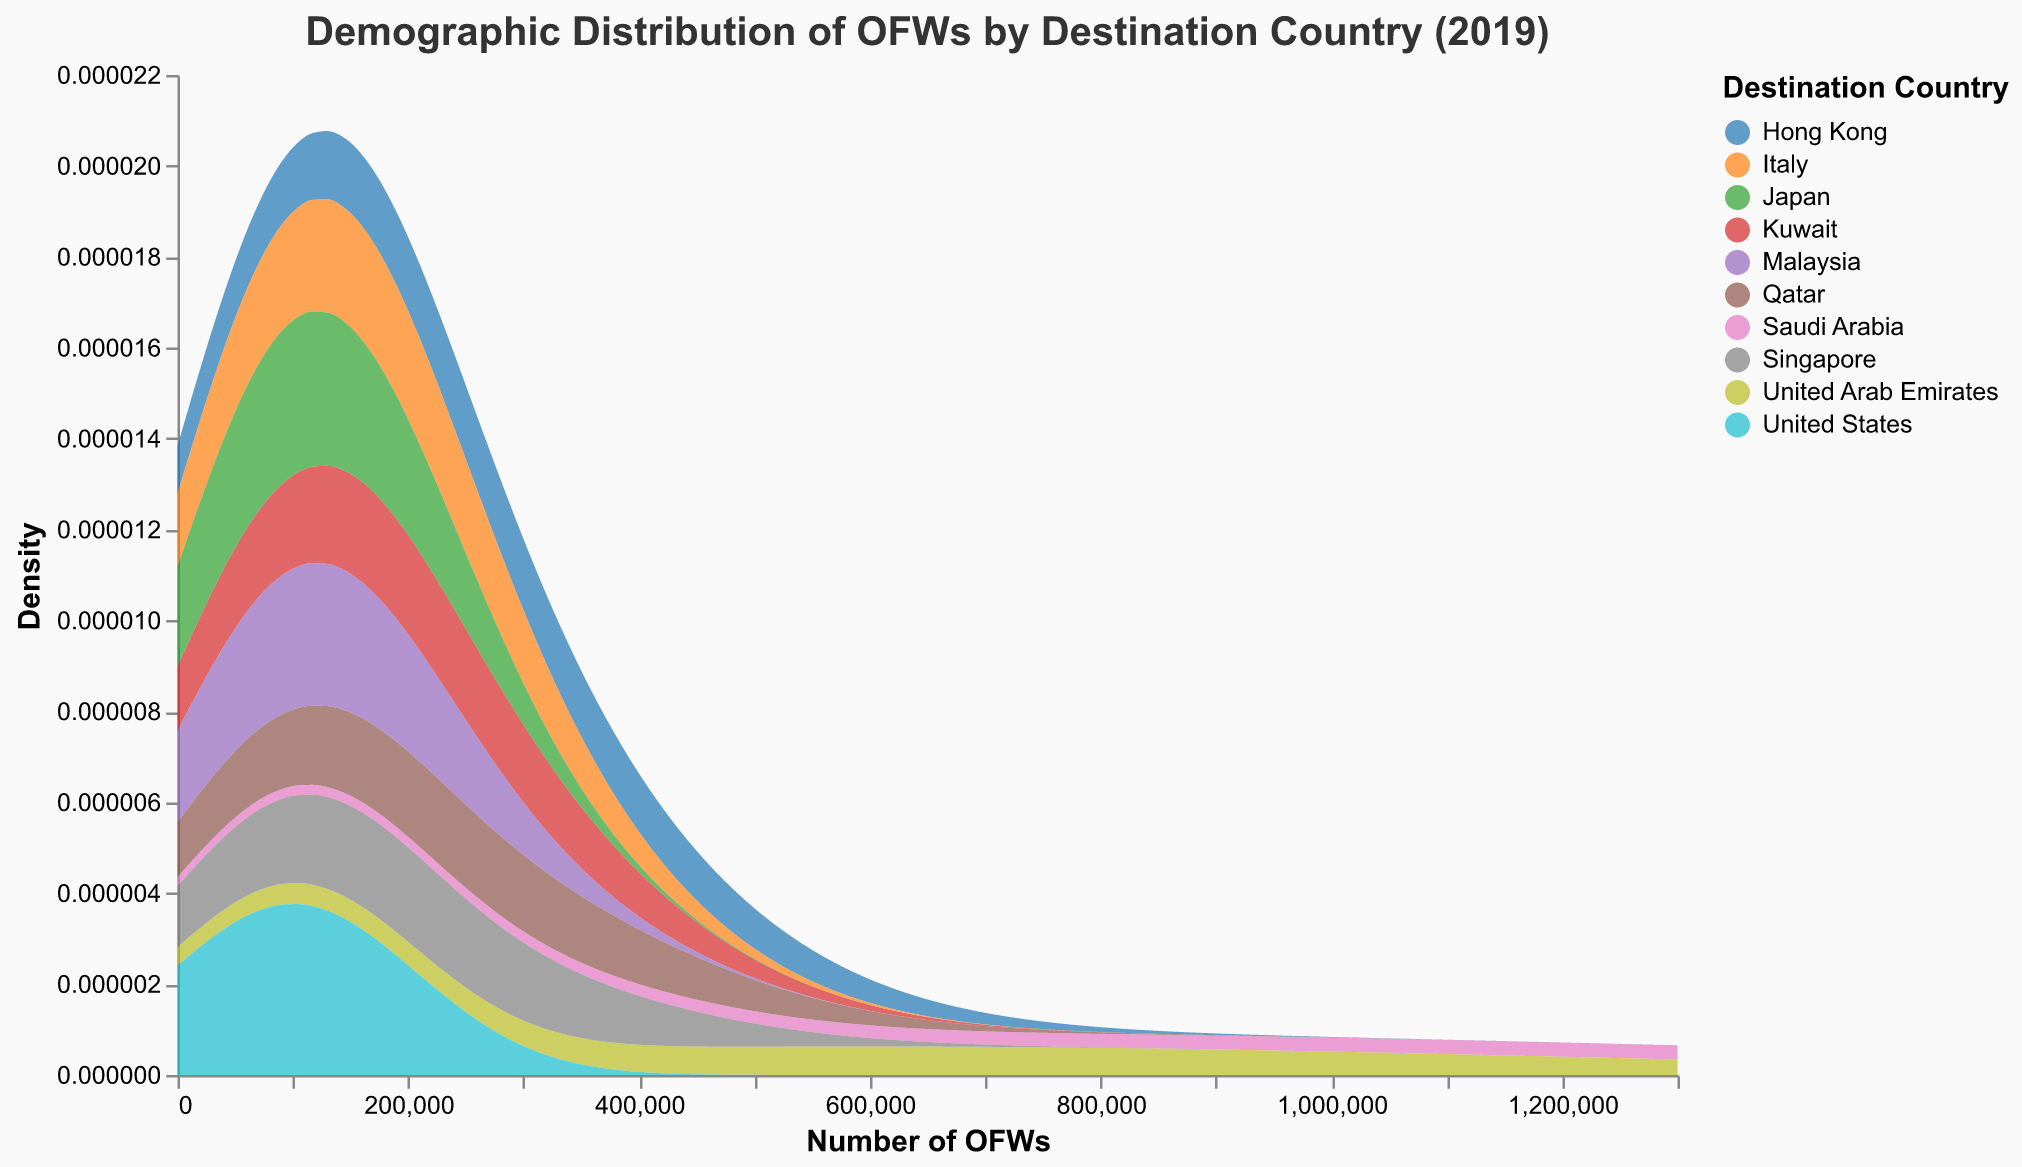What is the title of the figure? The title is clearly shown at the top of the figure.
Answer: Demographic Distribution of OFWs by Destination Country (2019) How many destination countries are represented in the figure? Count the number of different colors in the density plot, as each color corresponds to a different country.
Answer: 10 Which country has the highest density of OFWs? Identify the peak density for each country and find the one with the highest peak.
Answer: Saudi Arabia What is the range of the number of OFWs represented on the x-axis? Look at the x-axis labels to determine the minimum and maximum values.
Answer: 0 to 1,300,000 Which country has the second highest number of OFWs? Refer to the labels and the density plot to find the country with the second highest peak in density.
Answer: United Arab Emirates What is the color used to represent Italy in the figure? Identify the legend and find the color corresponding to Italy.
Answer: Specific color from the category10 scheme (e.g., red) How does the distribution of OFWs for Qatar compare to that for Singapore? Compare the density plots for Qatar and Singapore by looking at their shapes and peak values.
Answer: Qatar has a slightly higher peak density than Singapore Is there a country with a density plot that is significantly different from the others? If so, which one? Observe if any country's density plot stands out significantly in shape or peak from the others.
Answer: Saudi Arabia What is the approximate density value for Japan? Identify the density plot for Japan and observe the peak value on the y-axis.
Answer: Approximately 0.00001 (example value) Between Malaysia and Japan, which country has a higher density of OFWs? Compare the peak density values for Malaysia and Japan.
Answer: Malaysia 